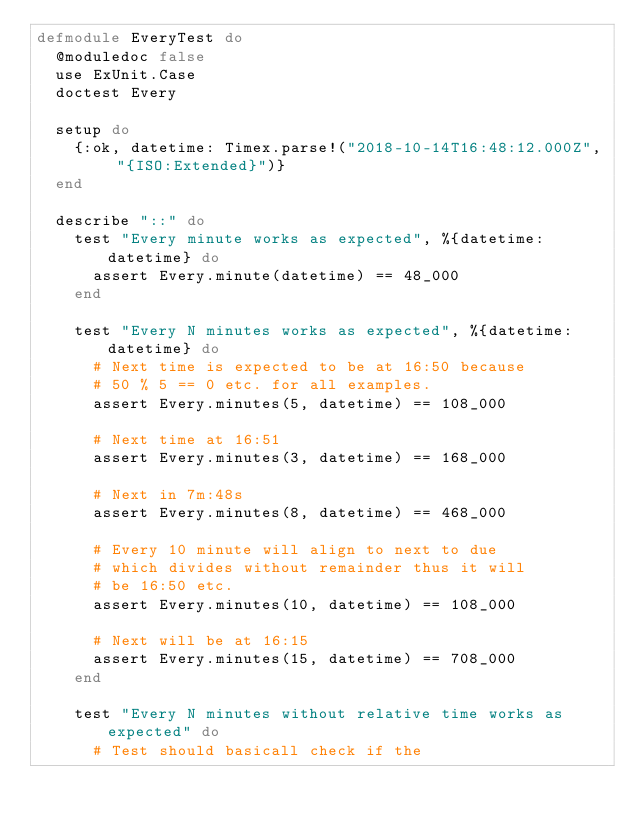Convert code to text. <code><loc_0><loc_0><loc_500><loc_500><_Elixir_>defmodule EveryTest do
  @moduledoc false
  use ExUnit.Case
  doctest Every

  setup do
    {:ok, datetime: Timex.parse!("2018-10-14T16:48:12.000Z", "{ISO:Extended}")}
  end

  describe "::" do
    test "Every minute works as expected", %{datetime: datetime} do
      assert Every.minute(datetime) == 48_000
    end

    test "Every N minutes works as expected", %{datetime: datetime} do
      # Next time is expected to be at 16:50 because
      # 50 % 5 == 0 etc. for all examples.
      assert Every.minutes(5, datetime) == 108_000

      # Next time at 16:51
      assert Every.minutes(3, datetime) == 168_000

      # Next in 7m:48s
      assert Every.minutes(8, datetime) == 468_000

      # Every 10 minute will align to next to due
      # which divides without remainder thus it will
      # be 16:50 etc.
      assert Every.minutes(10, datetime) == 108_000

      # Next will be at 16:15
      assert Every.minutes(15, datetime) == 708_000
    end

    test "Every N minutes without relative time works as expected" do
      # Test should basicall check if the</code> 